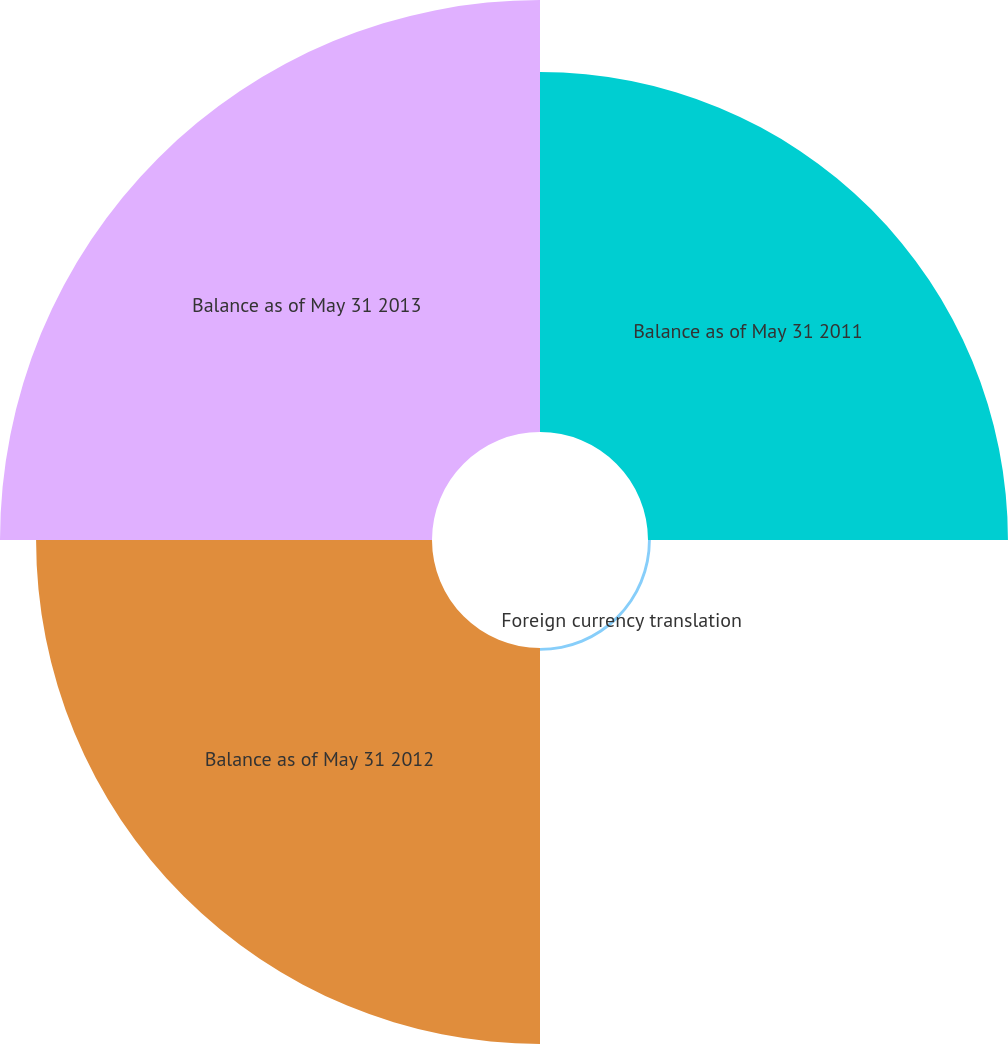Convert chart. <chart><loc_0><loc_0><loc_500><loc_500><pie_chart><fcel>Balance as of May 31 2011<fcel>Foreign currency translation<fcel>Balance as of May 31 2012<fcel>Balance as of May 31 2013<nl><fcel>30.23%<fcel>0.24%<fcel>33.25%<fcel>36.28%<nl></chart> 